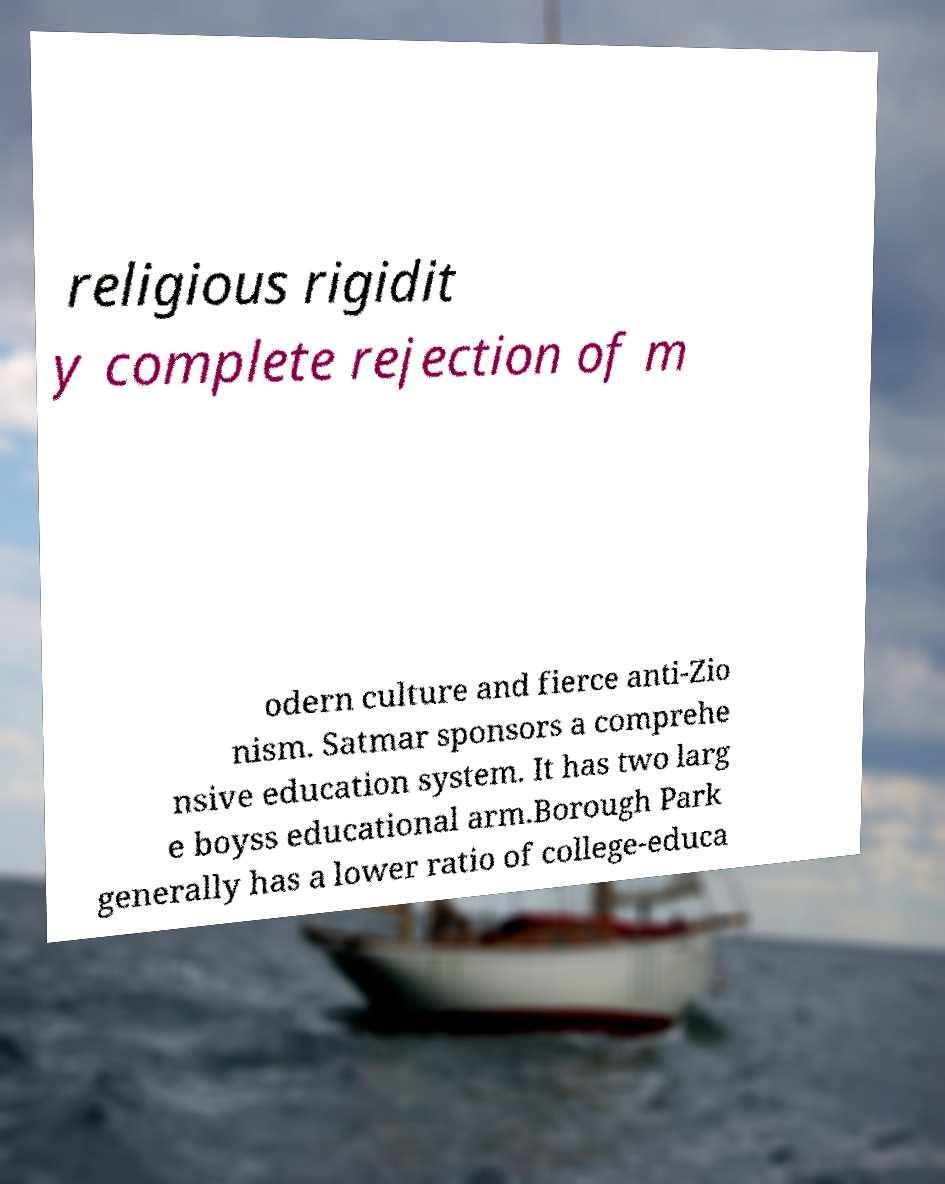Can you accurately transcribe the text from the provided image for me? religious rigidit y complete rejection of m odern culture and fierce anti-Zio nism. Satmar sponsors a comprehe nsive education system. It has two larg e boyss educational arm.Borough Park generally has a lower ratio of college-educa 